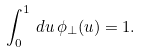Convert formula to latex. <formula><loc_0><loc_0><loc_500><loc_500>\int _ { 0 } ^ { 1 } \, d u \, \phi _ { \perp } ( u ) = 1 .</formula> 